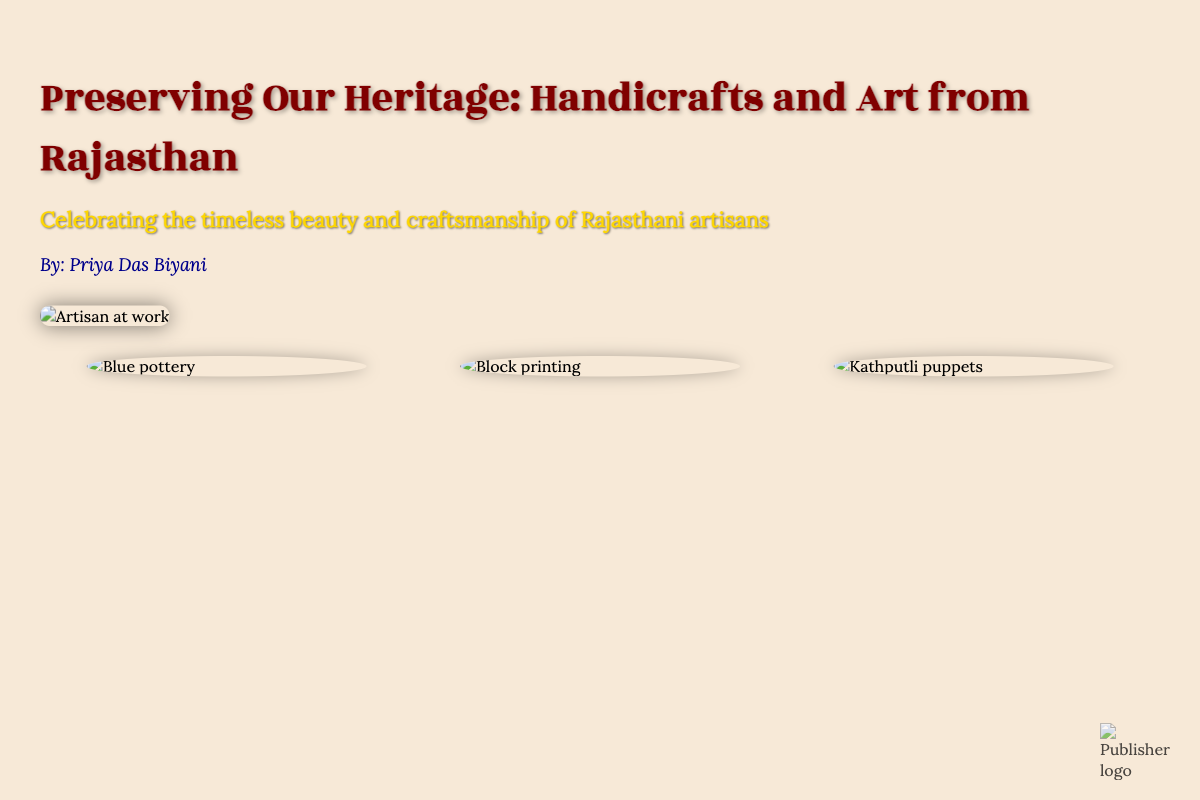what is the title of the book? The title is prominently displayed on the cover in large font.
Answer: Preserving Our Heritage: Handicrafts and Art from Rajasthan who is the author of the book? The author's name is written below the title on the cover.
Answer: Priya Das Biyani what type of artistry is highlighted in the book? The subtitle gives insight into the theme by mentioning artisan craftsmanship.
Answer: Handicrafts and Art what is the main visual on the cover? The main visual is an image showing an artisan engaged in crafting.
Answer: Artisan at work which handicraft is represented by blue pottery? There is an image of blue pottery included as highlighted items in the design.
Answer: Blue pottery what color is used for the subtitle text? The color of the subtitle stands out against the background and is noted in the style.
Answer: Gold how many highlighted items are featured on the cover? The document indicates a layout with a specific number of featured handicrafts.
Answer: Three what is the background color of the cover? The background color of the document set the tone for the overall design.
Answer: #f7e9d7 (a light beige) where is the publisher logo located? The document describes the position of the publisher's logo on the cover.
Answer: Bottom right 